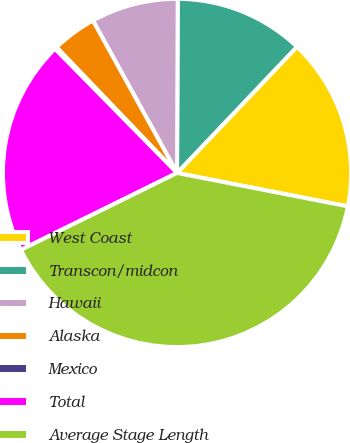Convert chart. <chart><loc_0><loc_0><loc_500><loc_500><pie_chart><fcel>West Coast<fcel>Transcon/midcon<fcel>Hawaii<fcel>Alaska<fcel>Mexico<fcel>Total<fcel>Average Stage Length<nl><fcel>15.98%<fcel>12.03%<fcel>8.09%<fcel>4.14%<fcel>0.2%<fcel>19.92%<fcel>39.64%<nl></chart> 